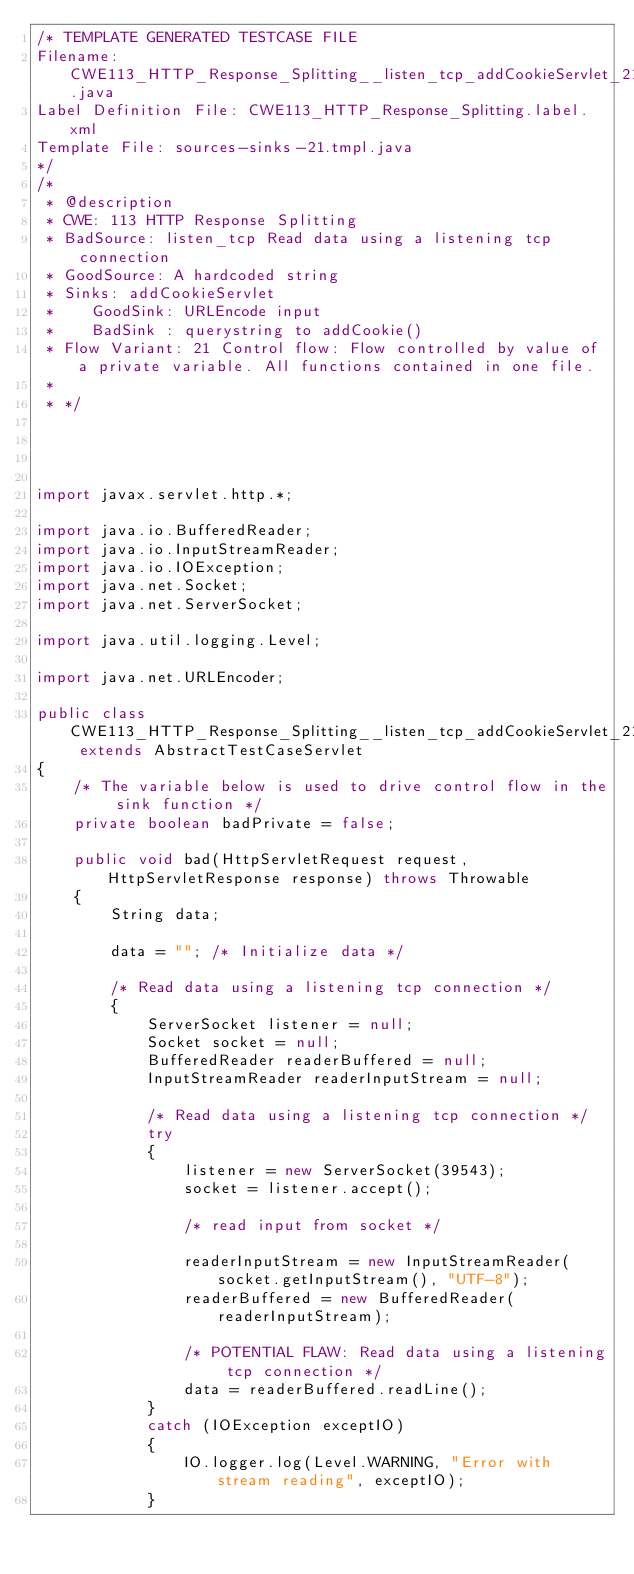Convert code to text. <code><loc_0><loc_0><loc_500><loc_500><_Java_>/* TEMPLATE GENERATED TESTCASE FILE
Filename: CWE113_HTTP_Response_Splitting__listen_tcp_addCookieServlet_21.java
Label Definition File: CWE113_HTTP_Response_Splitting.label.xml
Template File: sources-sinks-21.tmpl.java
*/
/*
 * @description
 * CWE: 113 HTTP Response Splitting
 * BadSource: listen_tcp Read data using a listening tcp connection
 * GoodSource: A hardcoded string
 * Sinks: addCookieServlet
 *    GoodSink: URLEncode input
 *    BadSink : querystring to addCookie()
 * Flow Variant: 21 Control flow: Flow controlled by value of a private variable. All functions contained in one file.
 *
 * */




import javax.servlet.http.*;

import java.io.BufferedReader;
import java.io.InputStreamReader;
import java.io.IOException;
import java.net.Socket;
import java.net.ServerSocket;

import java.util.logging.Level;

import java.net.URLEncoder;

public class CWE113_HTTP_Response_Splitting__listen_tcp_addCookieServlet_21 extends AbstractTestCaseServlet
{
    /* The variable below is used to drive control flow in the sink function */
    private boolean badPrivate = false;

    public void bad(HttpServletRequest request, HttpServletResponse response) throws Throwable
    {
        String data;

        data = ""; /* Initialize data */

        /* Read data using a listening tcp connection */
        {
            ServerSocket listener = null;
            Socket socket = null;
            BufferedReader readerBuffered = null;
            InputStreamReader readerInputStream = null;

            /* Read data using a listening tcp connection */
            try
            {
                listener = new ServerSocket(39543);
                socket = listener.accept();

                /* read input from socket */

                readerInputStream = new InputStreamReader(socket.getInputStream(), "UTF-8");
                readerBuffered = new BufferedReader(readerInputStream);

                /* POTENTIAL FLAW: Read data using a listening tcp connection */
                data = readerBuffered.readLine();
            }
            catch (IOException exceptIO)
            {
                IO.logger.log(Level.WARNING, "Error with stream reading", exceptIO);
            }</code> 